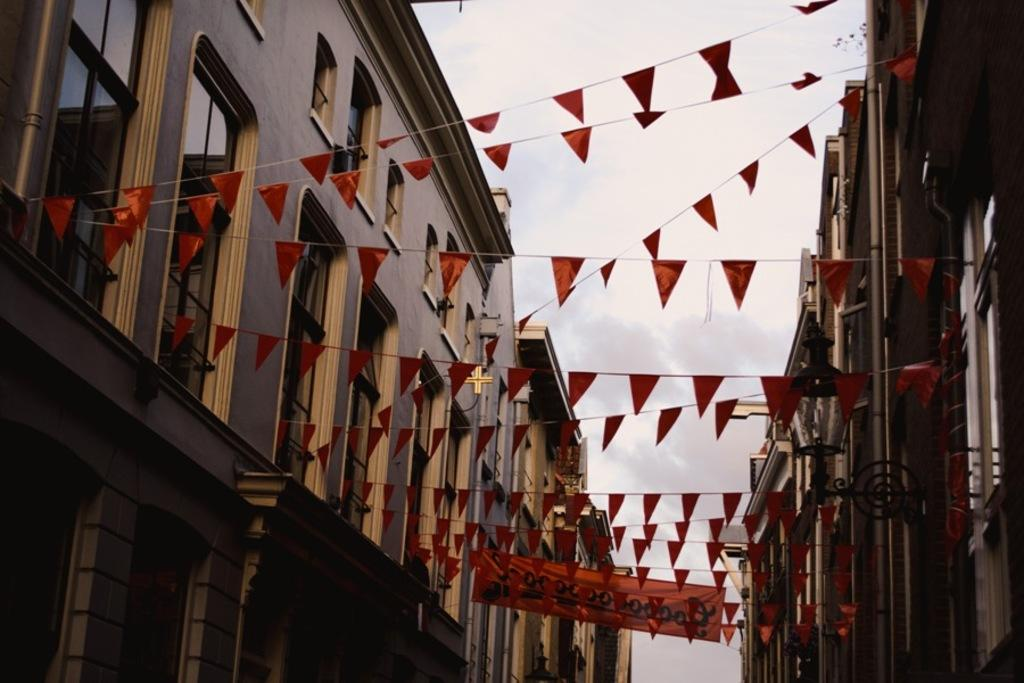What type of structures can be seen in the image? There are buildings in the image. What decorative elements are present on the buildings? There are flags in the image. What additional signage is visible in the image? There is a banner in the image. Can you describe any specific features of the buildings? There is a light attached to a building. What can be seen in the background of the image? The sky is visible in the background of the image, and there are clouds in the sky. Where is the dock located in the image? There is no dock present in the image. What type of credit can be seen on the banner in the image? There is no credit or financial information present on the banner in the image, as it only features buildings, flags, a banner, a light, and the sky with clouds. 